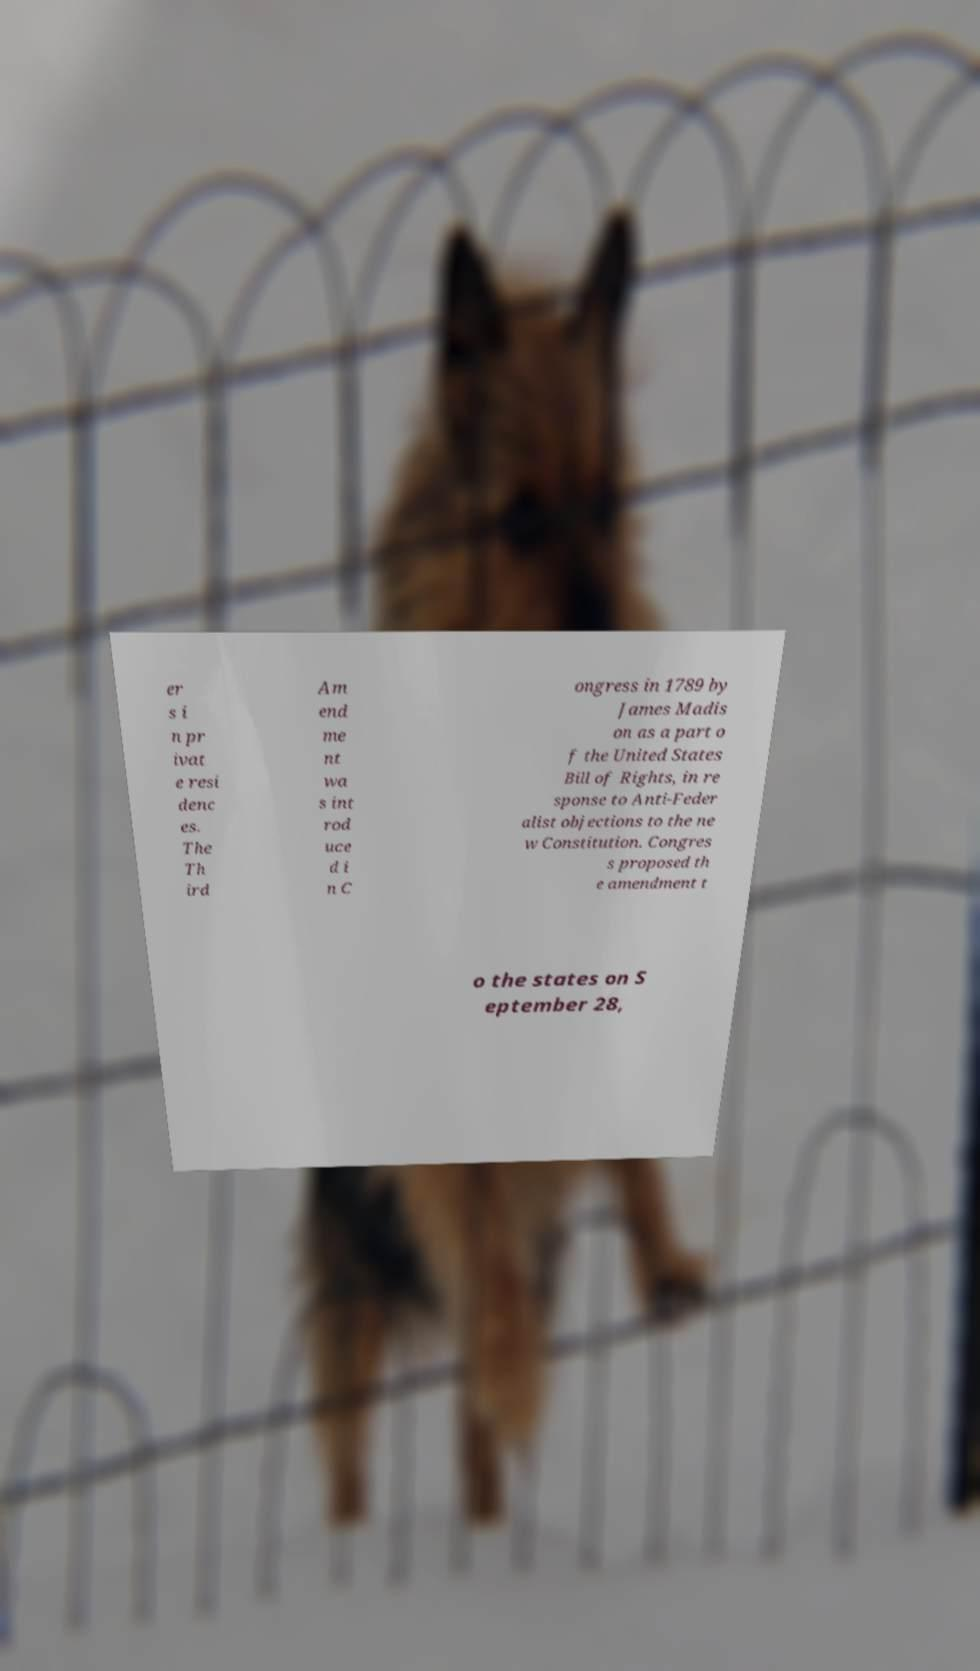Can you read and provide the text displayed in the image?This photo seems to have some interesting text. Can you extract and type it out for me? er s i n pr ivat e resi denc es. The Th ird Am end me nt wa s int rod uce d i n C ongress in 1789 by James Madis on as a part o f the United States Bill of Rights, in re sponse to Anti-Feder alist objections to the ne w Constitution. Congres s proposed th e amendment t o the states on S eptember 28, 